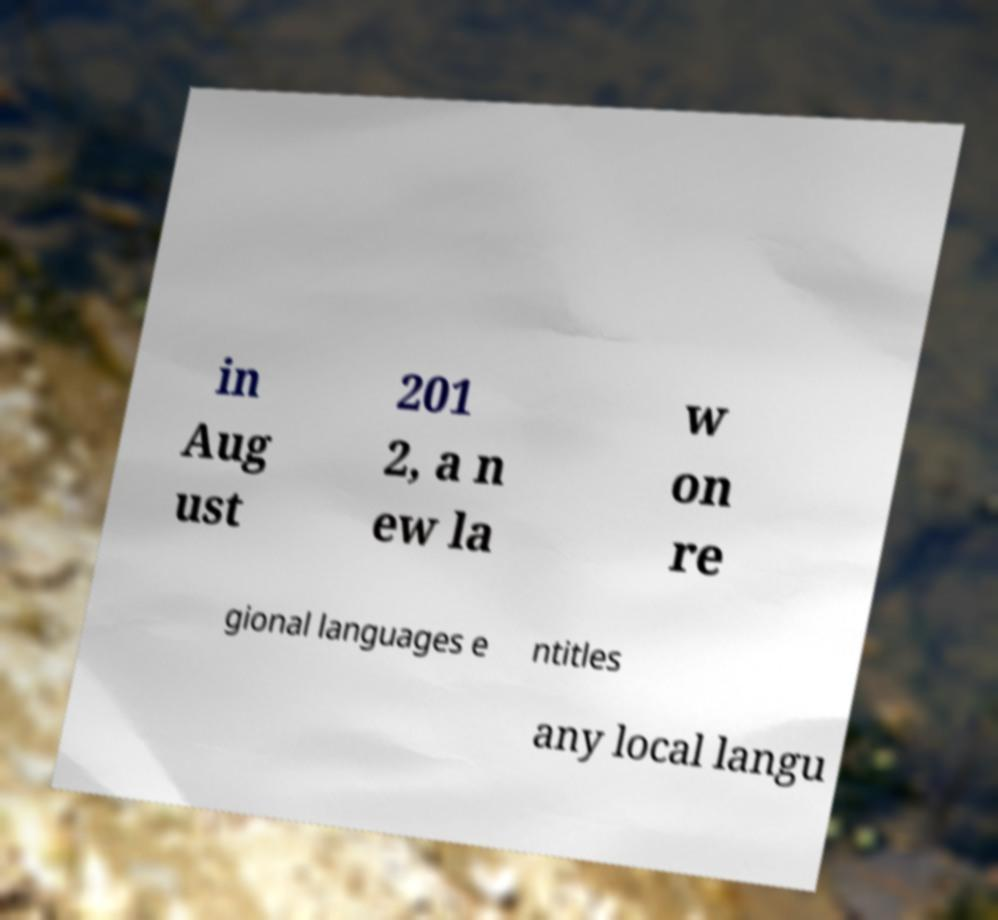Please identify and transcribe the text found in this image. in Aug ust 201 2, a n ew la w on re gional languages e ntitles any local langu 